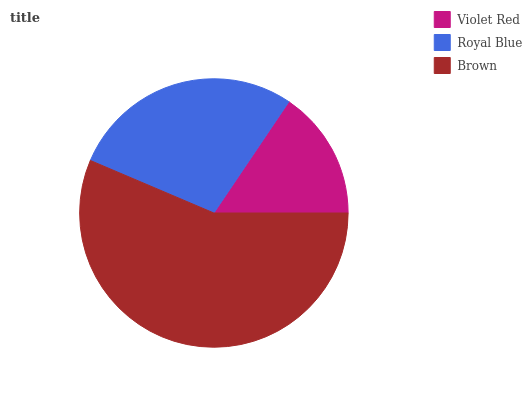Is Violet Red the minimum?
Answer yes or no. Yes. Is Brown the maximum?
Answer yes or no. Yes. Is Royal Blue the minimum?
Answer yes or no. No. Is Royal Blue the maximum?
Answer yes or no. No. Is Royal Blue greater than Violet Red?
Answer yes or no. Yes. Is Violet Red less than Royal Blue?
Answer yes or no. Yes. Is Violet Red greater than Royal Blue?
Answer yes or no. No. Is Royal Blue less than Violet Red?
Answer yes or no. No. Is Royal Blue the high median?
Answer yes or no. Yes. Is Royal Blue the low median?
Answer yes or no. Yes. Is Brown the high median?
Answer yes or no. No. Is Brown the low median?
Answer yes or no. No. 